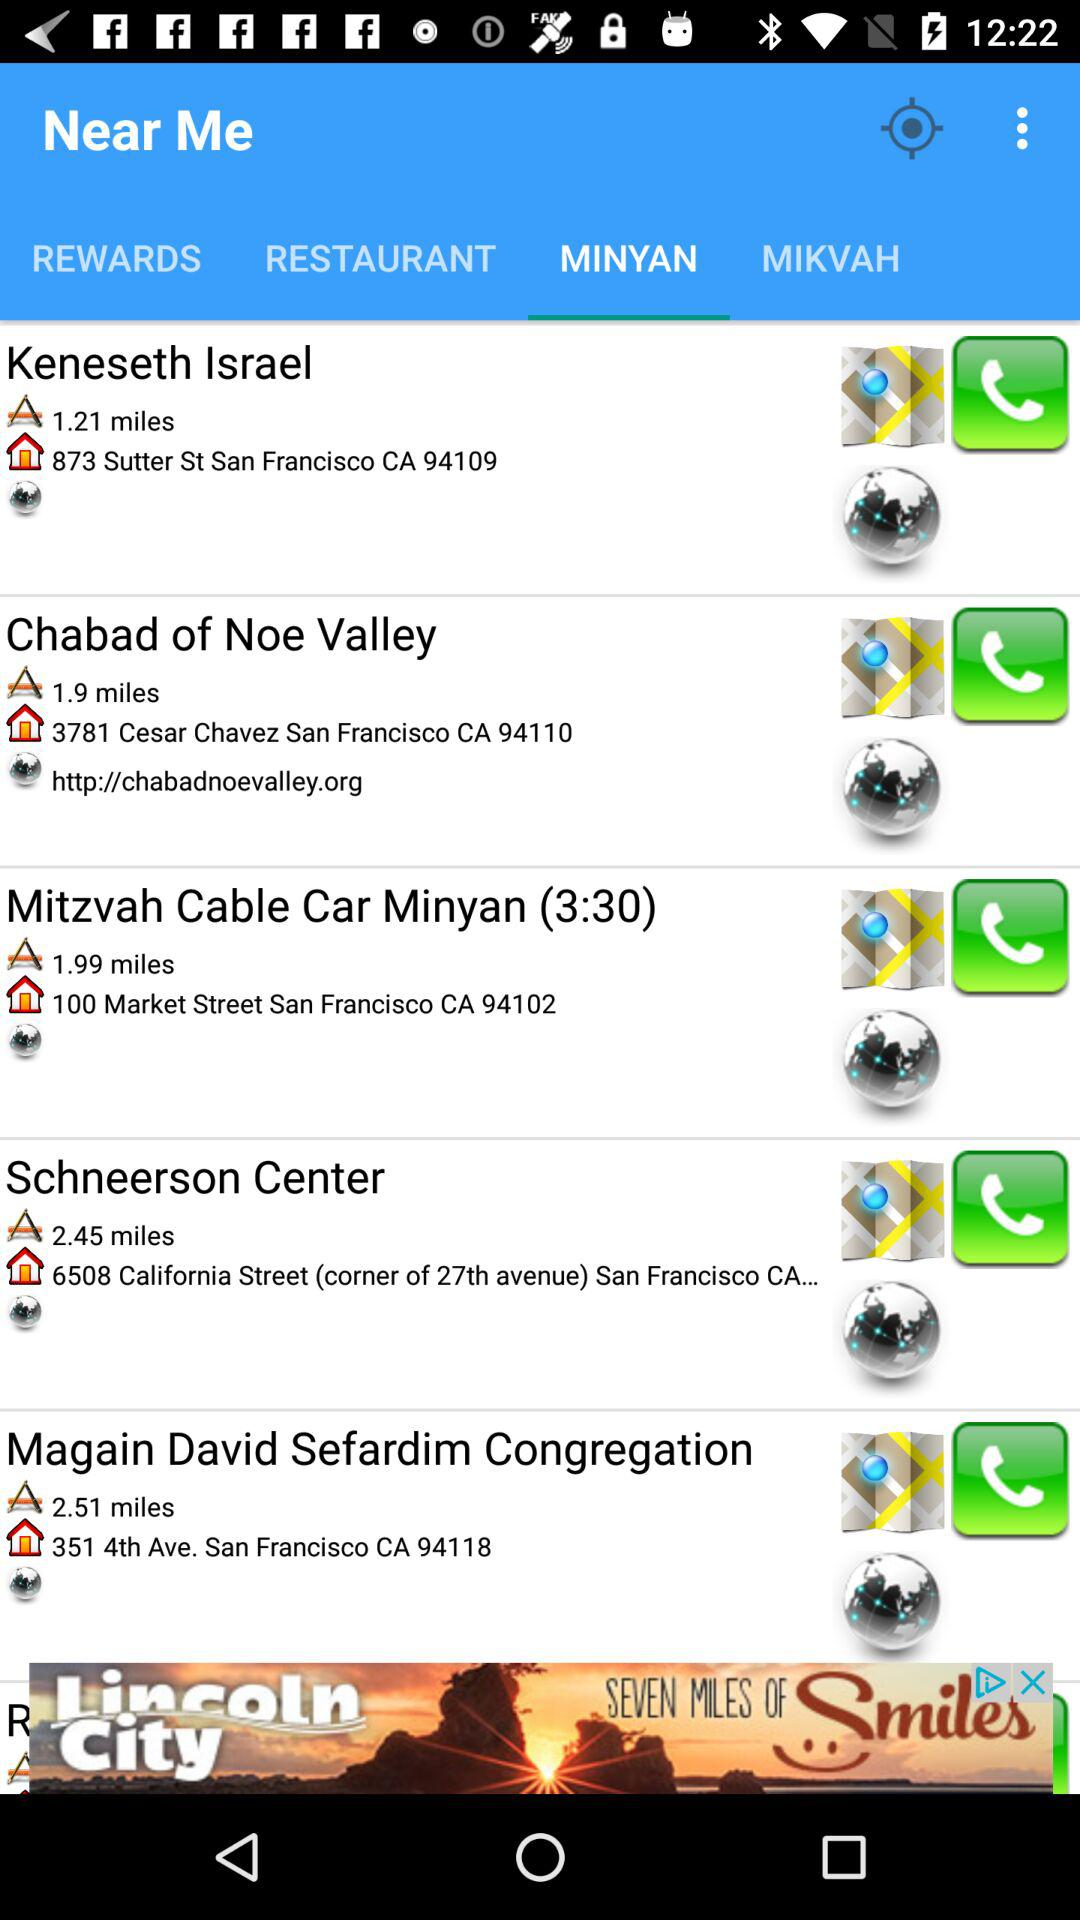What is the address of the Chabad of Noe Valley? The address is 3781 Cesar Chavez San Francisco CA 94110. 